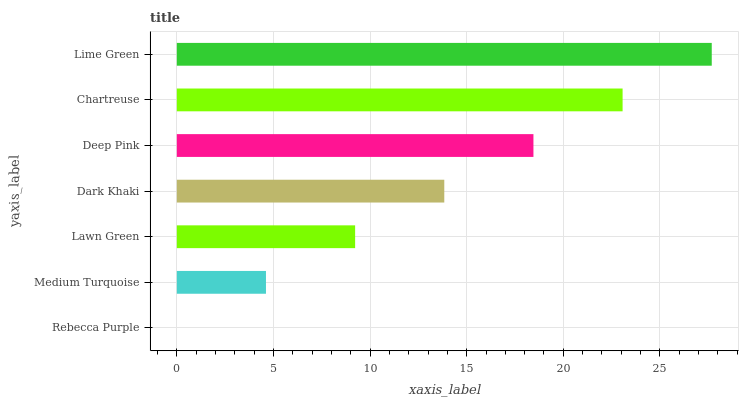Is Rebecca Purple the minimum?
Answer yes or no. Yes. Is Lime Green the maximum?
Answer yes or no. Yes. Is Medium Turquoise the minimum?
Answer yes or no. No. Is Medium Turquoise the maximum?
Answer yes or no. No. Is Medium Turquoise greater than Rebecca Purple?
Answer yes or no. Yes. Is Rebecca Purple less than Medium Turquoise?
Answer yes or no. Yes. Is Rebecca Purple greater than Medium Turquoise?
Answer yes or no. No. Is Medium Turquoise less than Rebecca Purple?
Answer yes or no. No. Is Dark Khaki the high median?
Answer yes or no. Yes. Is Dark Khaki the low median?
Answer yes or no. Yes. Is Rebecca Purple the high median?
Answer yes or no. No. Is Chartreuse the low median?
Answer yes or no. No. 